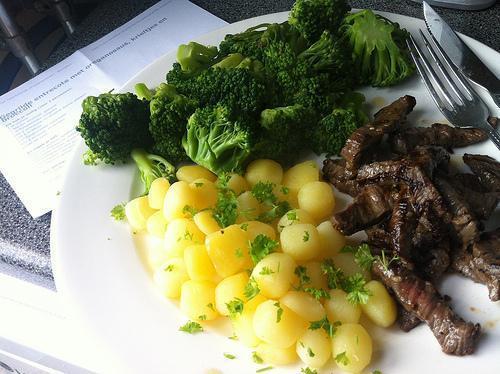How many items of food?
Give a very brief answer. 3. 